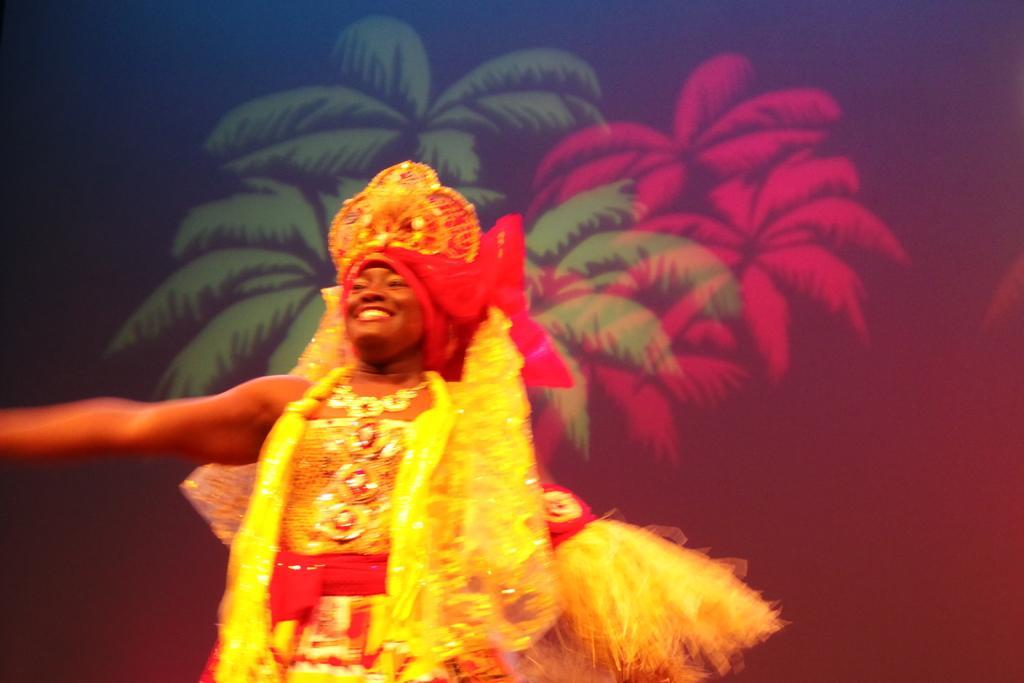How would you summarize this image in a sentence or two? Here in this picture we can see a person wearing a costume and standing over a place and we can see the person is smiling and behind him we can see some design of trees present. 